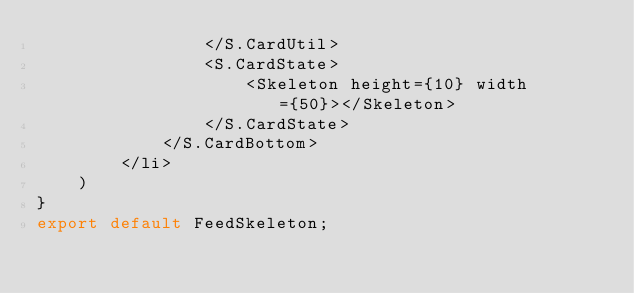Convert code to text. <code><loc_0><loc_0><loc_500><loc_500><_TypeScript_>                </S.CardUtil>
                <S.CardState>
                    <Skeleton height={10} width={50}></Skeleton>
                </S.CardState>
            </S.CardBottom>
        </li>
    )
}   
export default FeedSkeleton;</code> 